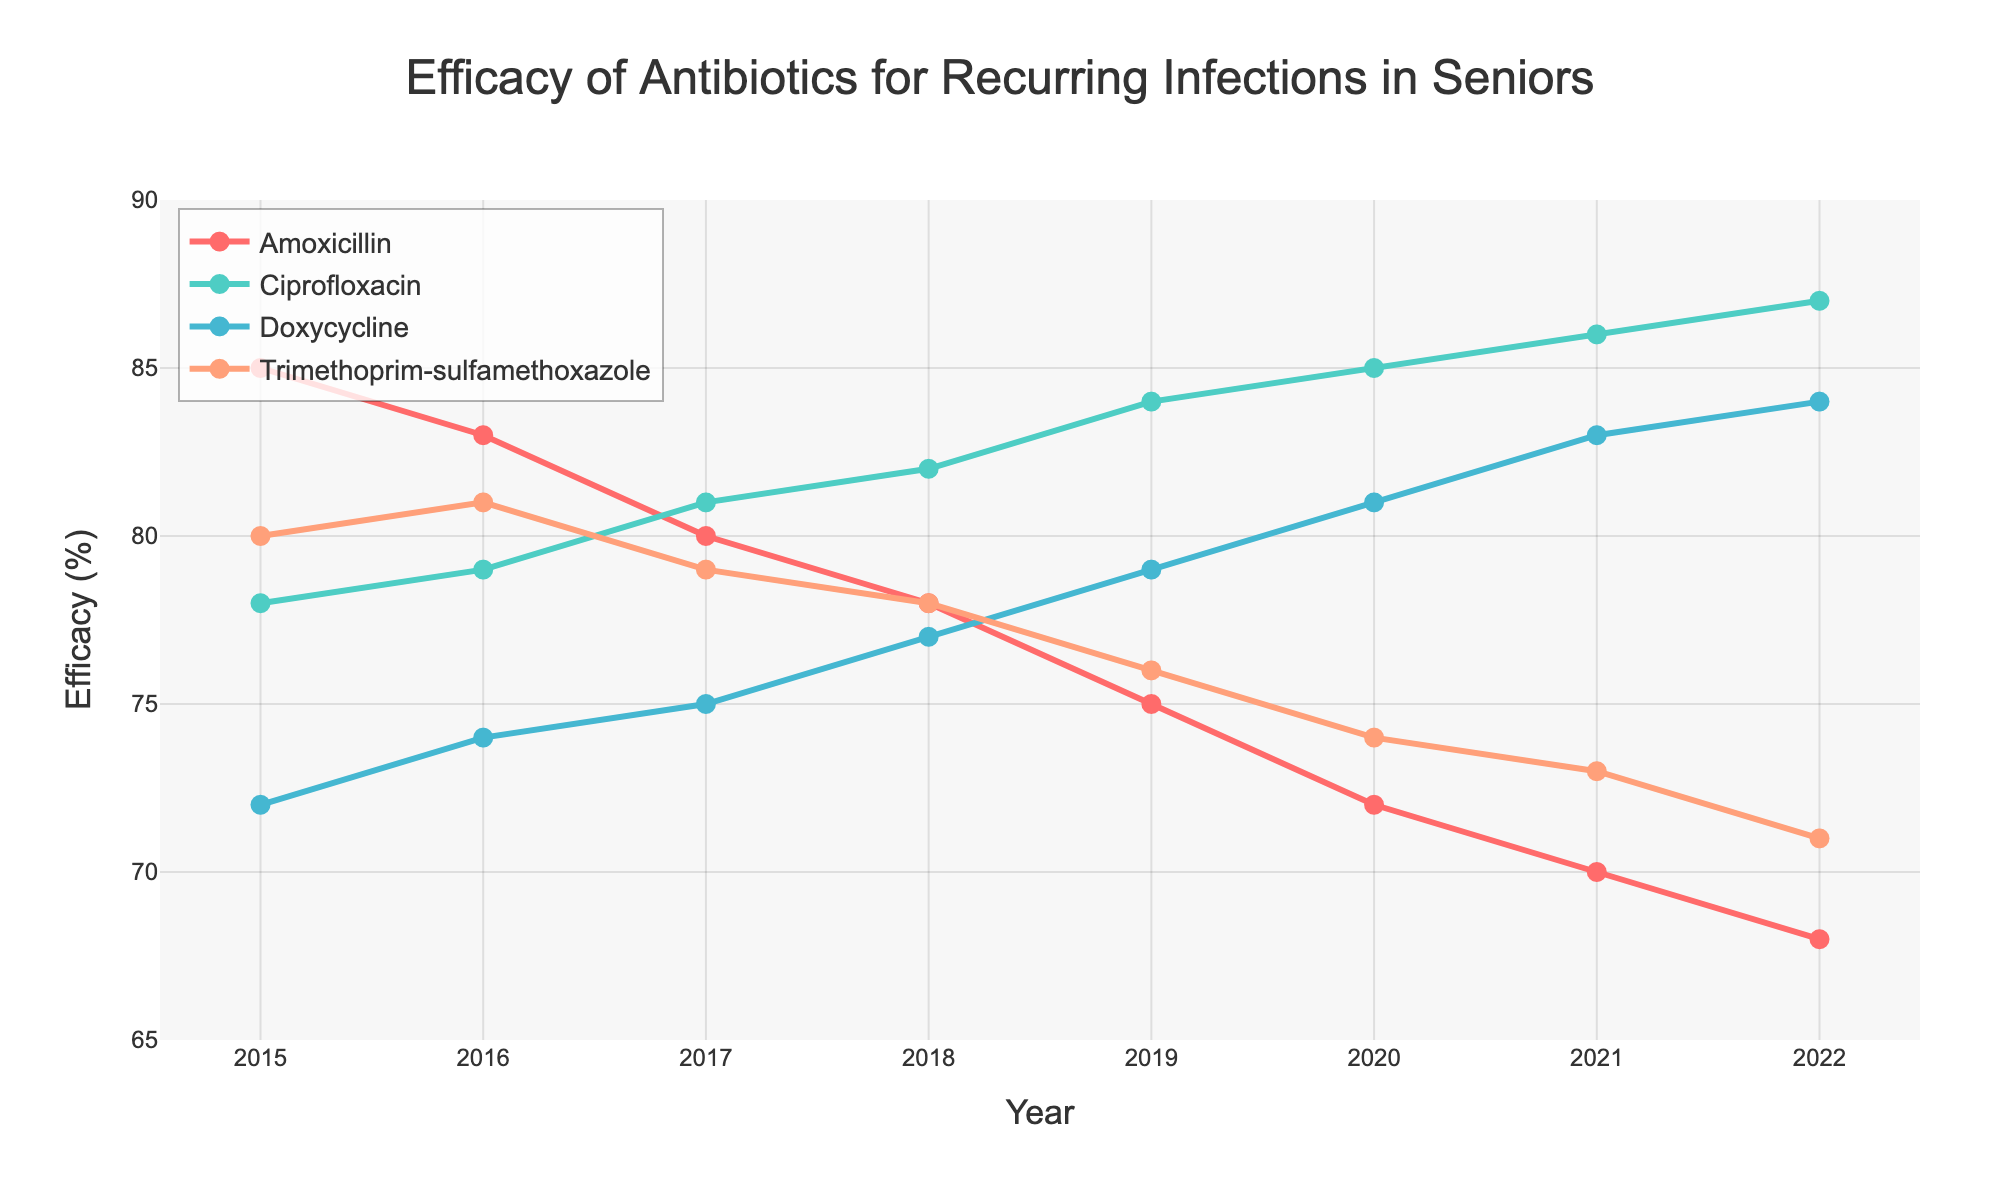Which antibiotic had the highest efficacy in 2022? Look at the values for each antibiotic in 2022 and identify the highest one. Ciprofloxacin has an efficacy of 87%, which is the highest.
Answer: Ciprofloxacin Which antibiotic showed the greatest decrease in efficacy from 2015 to 2022? Subtract the 2022 efficacy from the 2015 efficacy for each antibiotic. Amoxicillin shows the greatest decrease from 85% to 68%, a decline of 17%.
Answer: Amoxicillin In which year did Doxycycline surpass Amoxicillin in efficacy for the first time? Compare the efficacy values of Doxycycline and Amoxicillin year by year. In 2018, Doxycycline (77%) surpasses Amoxicillin (78%).
Answer: 2018 What is the average efficacy of Trimethoprim-sulfamethoxazole over the 8 years? Add the efficacy values of Trimethoprim-sulfamethoxazole from each year and divide by the number of years. (80 + 81 + 79 + 78 + 76 + 74 + 73 + 71) / 8 = 75.25
Answer: 75.25 Between 2015 and 2022, which antibiotic had the most consistent efficacy (least fluctuation)? Evaluate the range (max - min) of efficacy for each antibiotic. Ciprofloxacin ranges from 78% to 87%, the least fluctuation (9%).
Answer: Ciprofloxacin Which two antibiotics had similar efficacy trends from 2015 to 2022? Compare the trends year by year for each antibiotic. Both Doxycycline and Ciprofloxacin have increasing trends in their efficacy values.
Answer: Doxycycline and Ciprofloxacin In which year was the efficacy of Amoxicillin equal to the efficacy of Trimethoprim-sulfamethoxazole? Look for any year where both antibiotics have equal efficacy values. In none of the years do Amoxicillin and Trimethoprim-sulfamethoxazole have the same efficacy.
Answer: None Which antibiotic has shown an increase in efficacy every single year from 2015 to 2022? Check each year's values to see if there's consistent increase for any antibiotic. Only Ciprofloxacin shows a year-on-year increase from 78% in 2015 to 87% in 2022.
Answer: Ciprofloxacin 